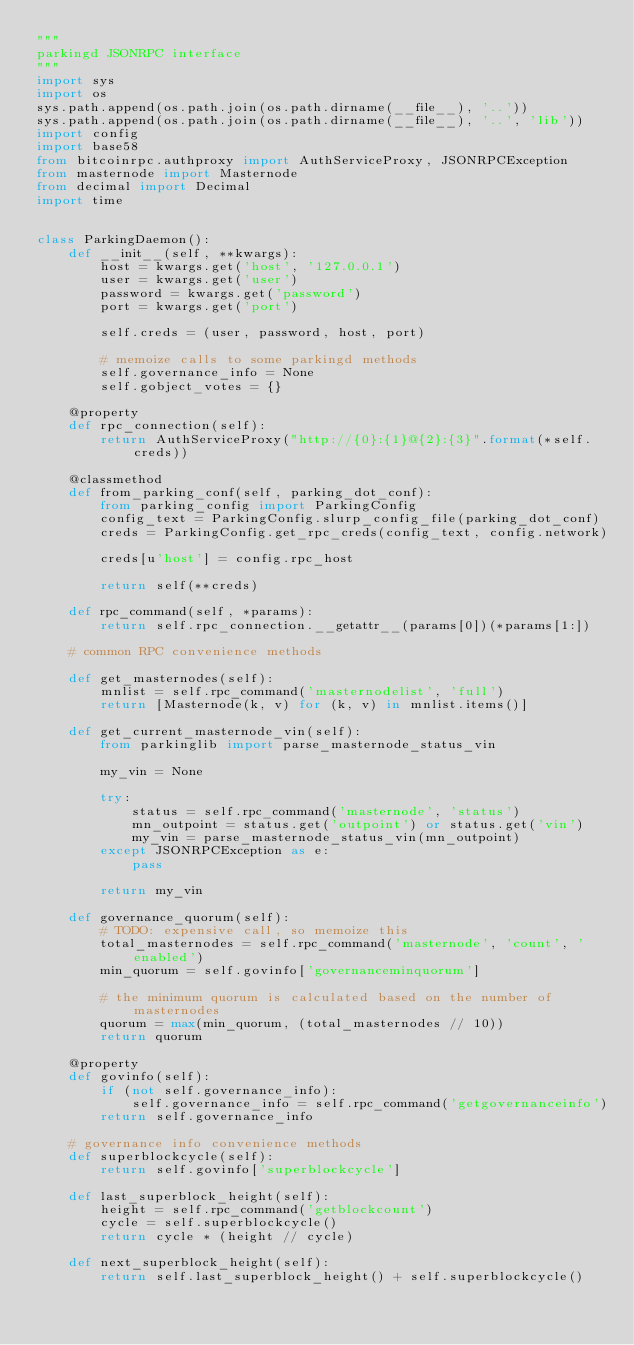Convert code to text. <code><loc_0><loc_0><loc_500><loc_500><_Python_>"""
parkingd JSONRPC interface
"""
import sys
import os
sys.path.append(os.path.join(os.path.dirname(__file__), '..'))
sys.path.append(os.path.join(os.path.dirname(__file__), '..', 'lib'))
import config
import base58
from bitcoinrpc.authproxy import AuthServiceProxy, JSONRPCException
from masternode import Masternode
from decimal import Decimal
import time


class ParkingDaemon():
    def __init__(self, **kwargs):
        host = kwargs.get('host', '127.0.0.1')
        user = kwargs.get('user')
        password = kwargs.get('password')
        port = kwargs.get('port')

        self.creds = (user, password, host, port)

        # memoize calls to some parkingd methods
        self.governance_info = None
        self.gobject_votes = {}

    @property
    def rpc_connection(self):
        return AuthServiceProxy("http://{0}:{1}@{2}:{3}".format(*self.creds))

    @classmethod
    def from_parking_conf(self, parking_dot_conf):
        from parking_config import ParkingConfig
        config_text = ParkingConfig.slurp_config_file(parking_dot_conf)
        creds = ParkingConfig.get_rpc_creds(config_text, config.network)

        creds[u'host'] = config.rpc_host

        return self(**creds)

    def rpc_command(self, *params):
        return self.rpc_connection.__getattr__(params[0])(*params[1:])

    # common RPC convenience methods

    def get_masternodes(self):
        mnlist = self.rpc_command('masternodelist', 'full')
        return [Masternode(k, v) for (k, v) in mnlist.items()]

    def get_current_masternode_vin(self):
        from parkinglib import parse_masternode_status_vin

        my_vin = None

        try:
            status = self.rpc_command('masternode', 'status')
            mn_outpoint = status.get('outpoint') or status.get('vin')
            my_vin = parse_masternode_status_vin(mn_outpoint)
        except JSONRPCException as e:
            pass

        return my_vin

    def governance_quorum(self):
        # TODO: expensive call, so memoize this
        total_masternodes = self.rpc_command('masternode', 'count', 'enabled')
        min_quorum = self.govinfo['governanceminquorum']

        # the minimum quorum is calculated based on the number of masternodes
        quorum = max(min_quorum, (total_masternodes // 10))
        return quorum

    @property
    def govinfo(self):
        if (not self.governance_info):
            self.governance_info = self.rpc_command('getgovernanceinfo')
        return self.governance_info

    # governance info convenience methods
    def superblockcycle(self):
        return self.govinfo['superblockcycle']

    def last_superblock_height(self):
        height = self.rpc_command('getblockcount')
        cycle = self.superblockcycle()
        return cycle * (height // cycle)

    def next_superblock_height(self):
        return self.last_superblock_height() + self.superblockcycle()
</code> 